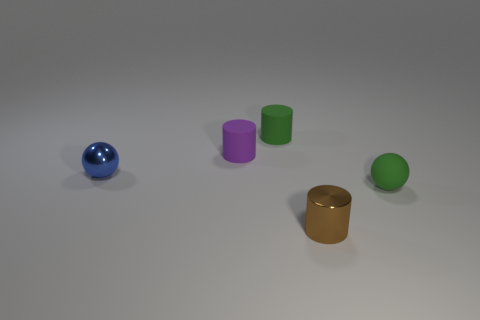Add 2 shiny cylinders. How many objects exist? 7 Subtract all balls. How many objects are left? 3 Add 3 cylinders. How many cylinders exist? 6 Subtract 0 cyan spheres. How many objects are left? 5 Subtract all tiny objects. Subtract all big brown balls. How many objects are left? 0 Add 4 small spheres. How many small spheres are left? 6 